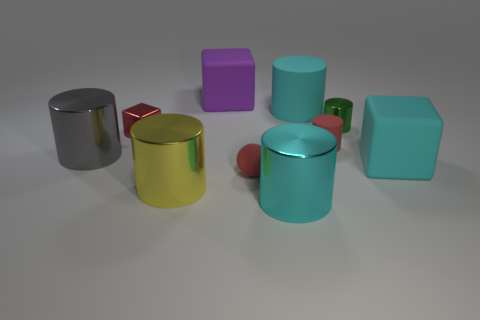What is the shape of the tiny matte thing that is the same color as the tiny rubber cylinder?
Ensure brevity in your answer.  Sphere. Is the material of the object to the left of the red cube the same as the tiny block?
Your response must be concise. Yes. What is the material of the red thing that is in front of the large rubber block that is in front of the large purple matte cube?
Provide a succinct answer. Rubber. What number of big yellow things have the same shape as the big cyan metallic thing?
Offer a very short reply. 1. There is a red metallic block left of the block right of the cylinder on the right side of the small matte cylinder; what size is it?
Your response must be concise. Small. How many yellow things are either metal blocks or matte blocks?
Provide a short and direct response. 0. Does the tiny red matte thing behind the gray metallic cylinder have the same shape as the large yellow metallic thing?
Keep it short and to the point. Yes. Are there more large cyan things behind the rubber ball than shiny balls?
Keep it short and to the point. Yes. How many gray rubber spheres have the same size as the cyan metallic object?
Keep it short and to the point. 0. There is a matte sphere that is the same color as the small rubber cylinder; what is its size?
Provide a short and direct response. Small. 